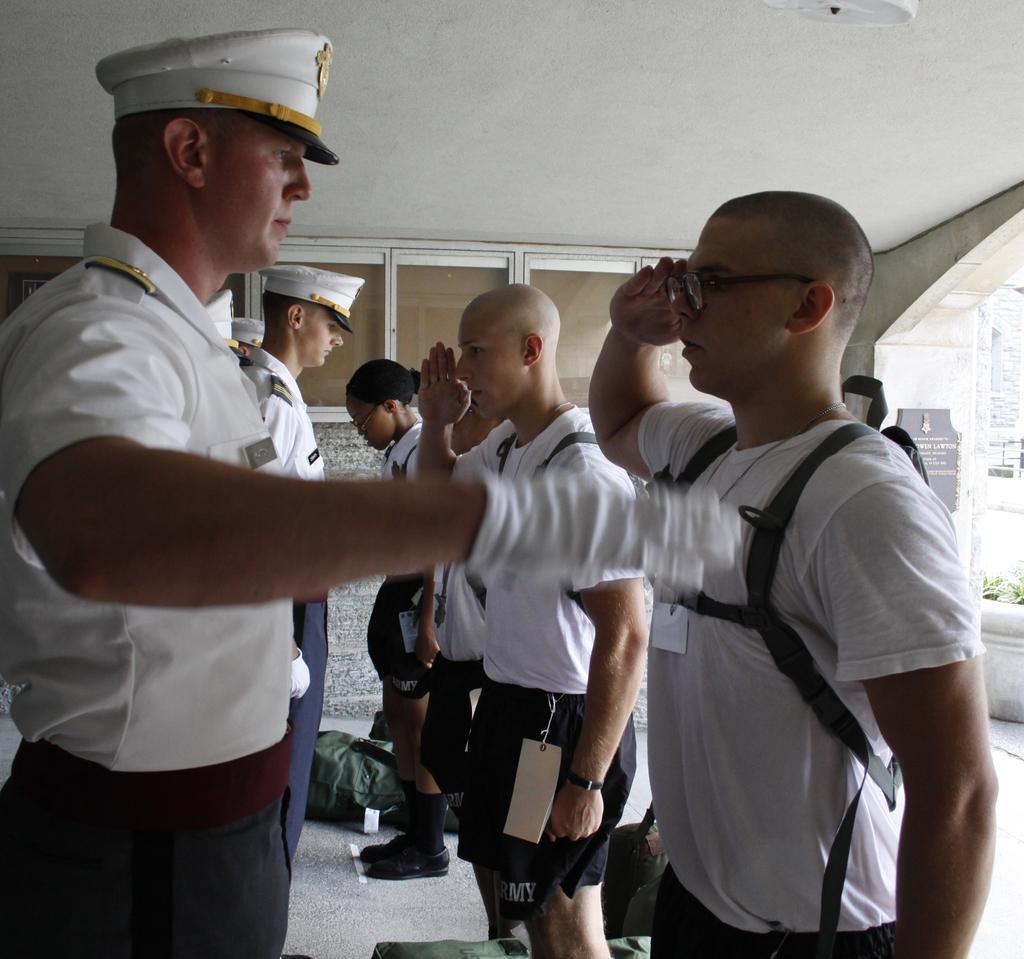Can you describe this image briefly? In this image I can see a group of people are standing on the floor and I can see bags. In the background I can see wall, houseplants, board and so on. This image is taken may be during a day. 